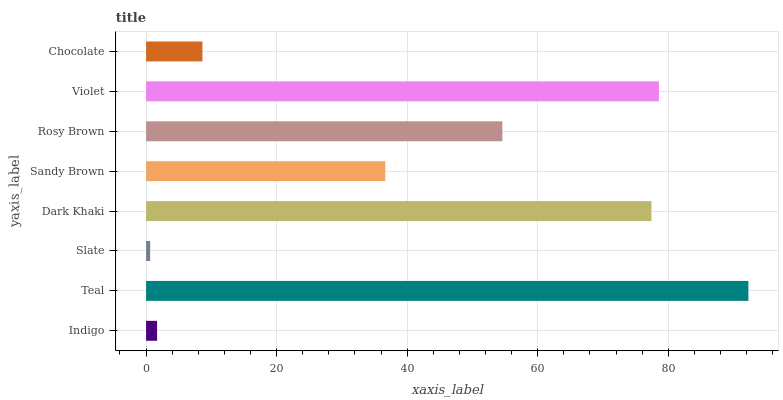Is Slate the minimum?
Answer yes or no. Yes. Is Teal the maximum?
Answer yes or no. Yes. Is Teal the minimum?
Answer yes or no. No. Is Slate the maximum?
Answer yes or no. No. Is Teal greater than Slate?
Answer yes or no. Yes. Is Slate less than Teal?
Answer yes or no. Yes. Is Slate greater than Teal?
Answer yes or no. No. Is Teal less than Slate?
Answer yes or no. No. Is Rosy Brown the high median?
Answer yes or no. Yes. Is Sandy Brown the low median?
Answer yes or no. Yes. Is Chocolate the high median?
Answer yes or no. No. Is Teal the low median?
Answer yes or no. No. 